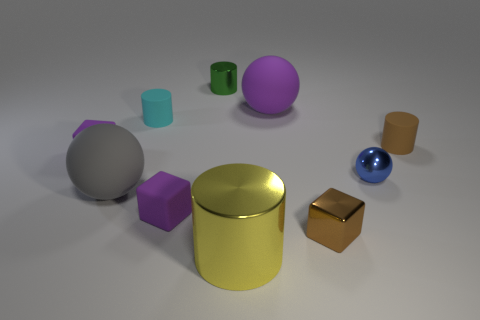Subtract all small metallic cylinders. How many cylinders are left? 3 Subtract all gray balls. How many balls are left? 2 Subtract 3 spheres. How many spheres are left? 0 Add 4 purple objects. How many purple objects are left? 7 Add 7 big objects. How many big objects exist? 10 Subtract 0 gray cubes. How many objects are left? 10 Subtract all balls. How many objects are left? 7 Subtract all blue blocks. Subtract all blue spheres. How many blocks are left? 3 Subtract all yellow blocks. How many blue balls are left? 1 Subtract all tiny brown shiny objects. Subtract all blue matte cubes. How many objects are left? 9 